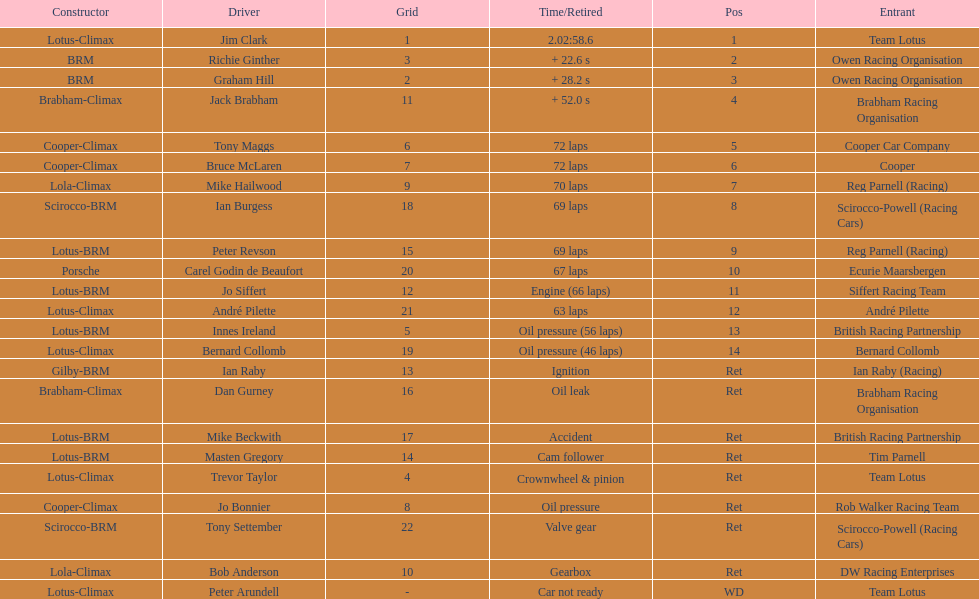Who came in earlier, tony maggs or jo siffert? Tony Maggs. 